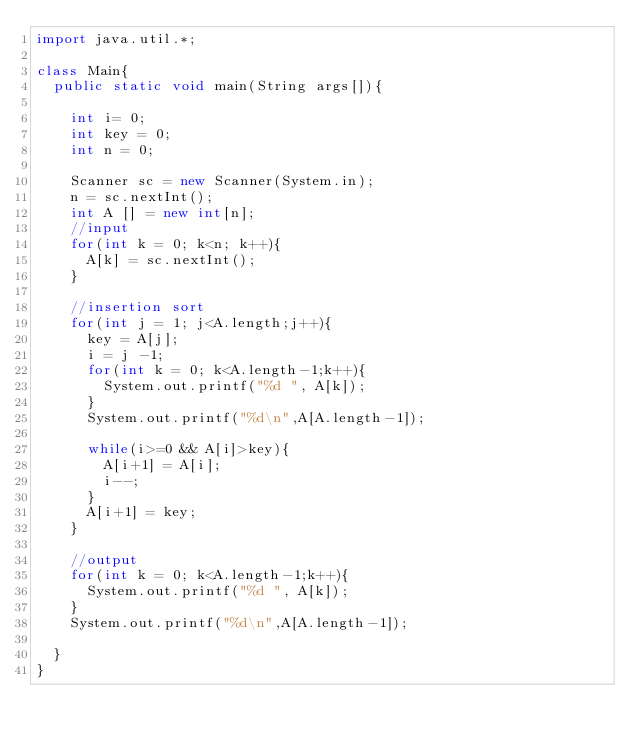<code> <loc_0><loc_0><loc_500><loc_500><_Java_>import java.util.*;

class Main{
  public static void main(String args[]){

    int i= 0;
    int key = 0;
    int n = 0;

    Scanner sc = new Scanner(System.in);
    n = sc.nextInt();
    int A [] = new int[n];
    //input
    for(int k = 0; k<n; k++){
      A[k] = sc.nextInt();
    }

    //insertion sort
    for(int j = 1; j<A.length;j++){
      key = A[j];
      i = j -1;
      for(int k = 0; k<A.length-1;k++){
        System.out.printf("%d ", A[k]);
      }
      System.out.printf("%d\n",A[A.length-1]);

      while(i>=0 && A[i]>key){
        A[i+1] = A[i];
        i--;
      }
      A[i+1] = key;
    }

    //output
    for(int k = 0; k<A.length-1;k++){
      System.out.printf("%d ", A[k]);
    }
    System.out.printf("%d\n",A[A.length-1]);

  }
}
</code> 